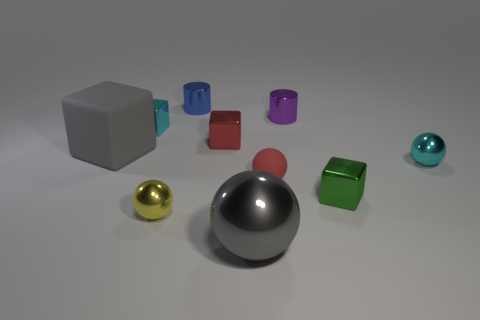What color is the rubber thing that is the same size as the blue shiny cylinder?
Keep it short and to the point. Red. How many cubes are purple shiny objects or tiny green metal things?
Offer a very short reply. 1. There is a small blue thing; does it have the same shape as the small purple object behind the tiny yellow metallic ball?
Make the answer very short. Yes. What number of cyan things have the same size as the purple shiny cylinder?
Your answer should be compact. 2. Do the tiny cyan object behind the red shiny thing and the big gray thing that is to the right of the small blue shiny cylinder have the same shape?
Your response must be concise. No. What is the shape of the other thing that is the same color as the small matte thing?
Ensure brevity in your answer.  Cube. There is a tiny metal sphere that is on the left side of the shiny object to the right of the green object; what is its color?
Your response must be concise. Yellow. There is another small thing that is the same shape as the tiny purple object; what is its color?
Provide a succinct answer. Blue. What size is the cyan object that is the same shape as the red metallic object?
Offer a very short reply. Small. There is a gray object on the left side of the blue shiny cylinder; what material is it?
Your response must be concise. Rubber. 